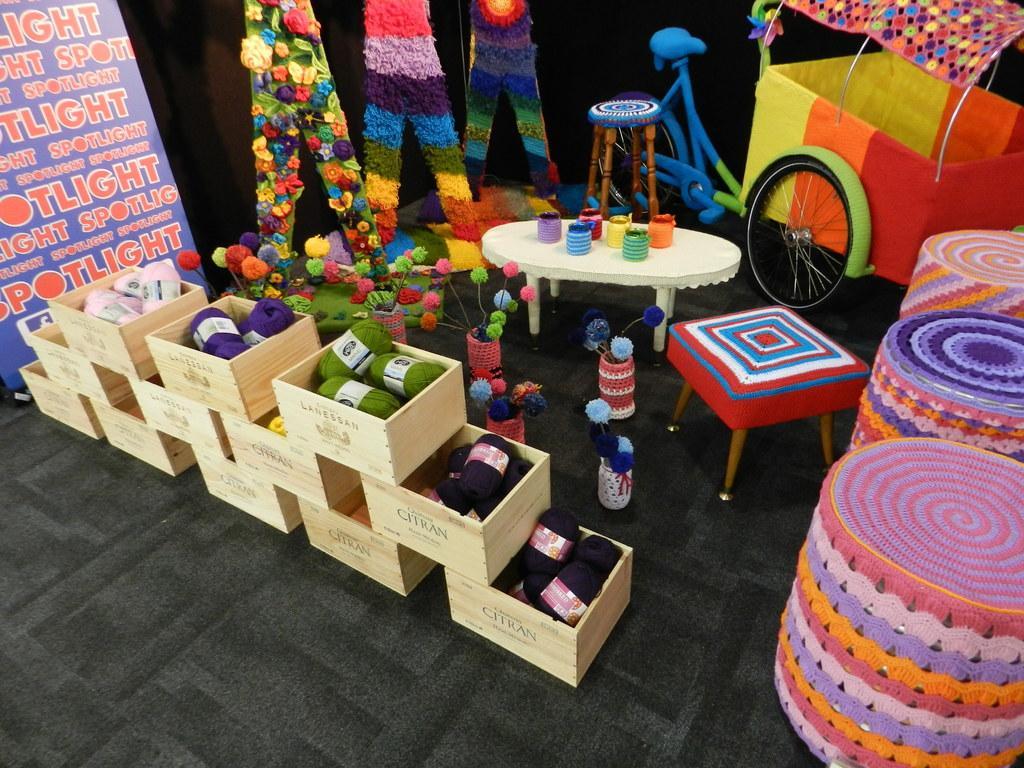Describe this image in one or two sentences. In this picture we can see some boxes on the floor. This is chair and there is a table. Here we can see a bicycle. And there is a banner. 